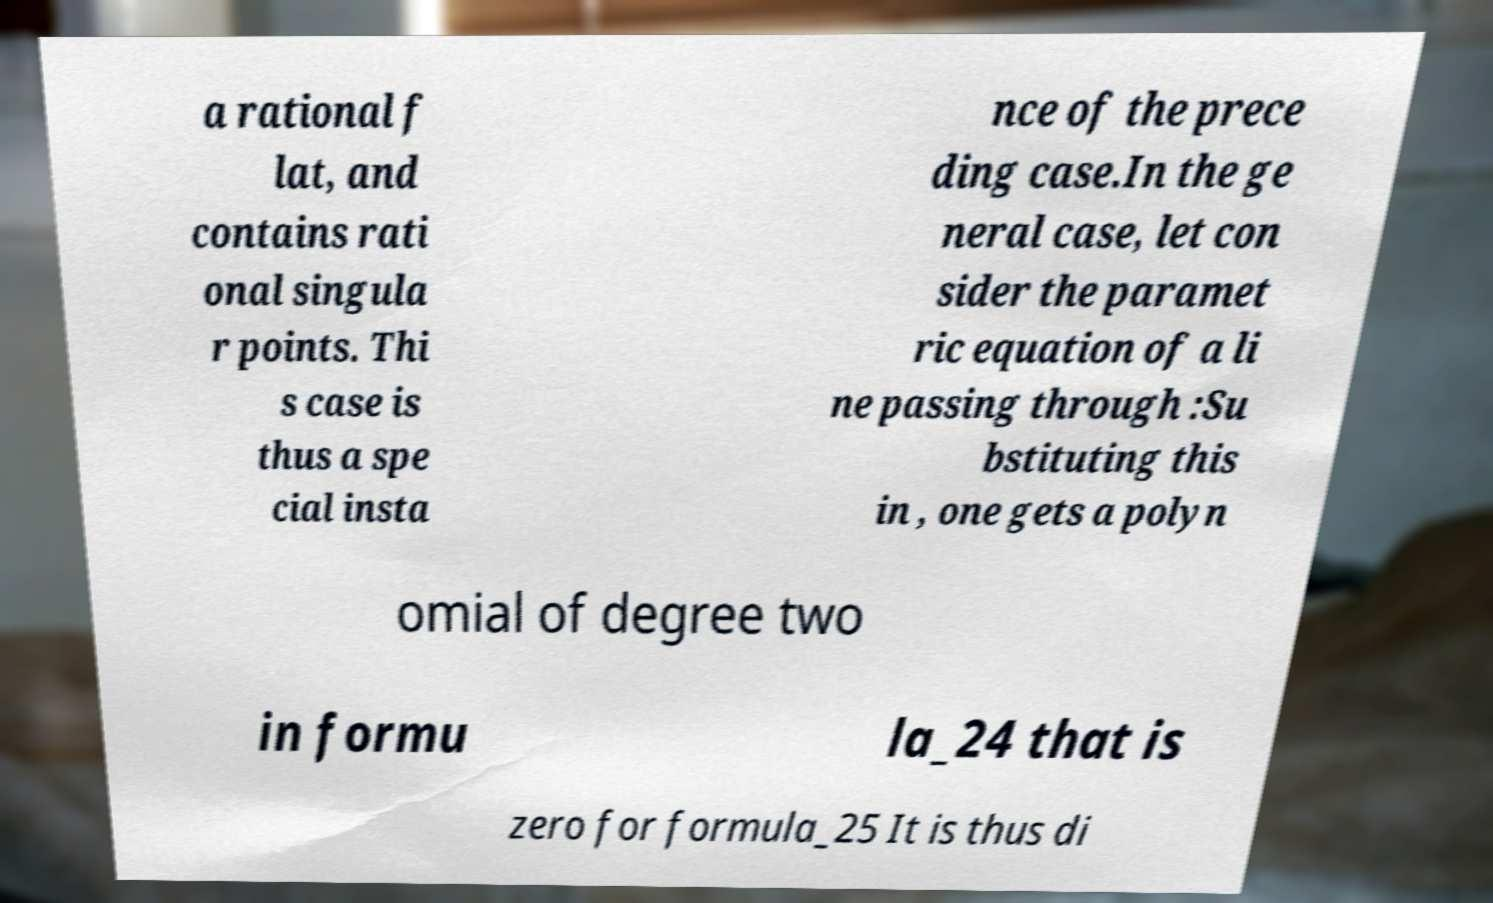I need the written content from this picture converted into text. Can you do that? a rational f lat, and contains rati onal singula r points. Thi s case is thus a spe cial insta nce of the prece ding case.In the ge neral case, let con sider the paramet ric equation of a li ne passing through :Su bstituting this in , one gets a polyn omial of degree two in formu la_24 that is zero for formula_25 It is thus di 